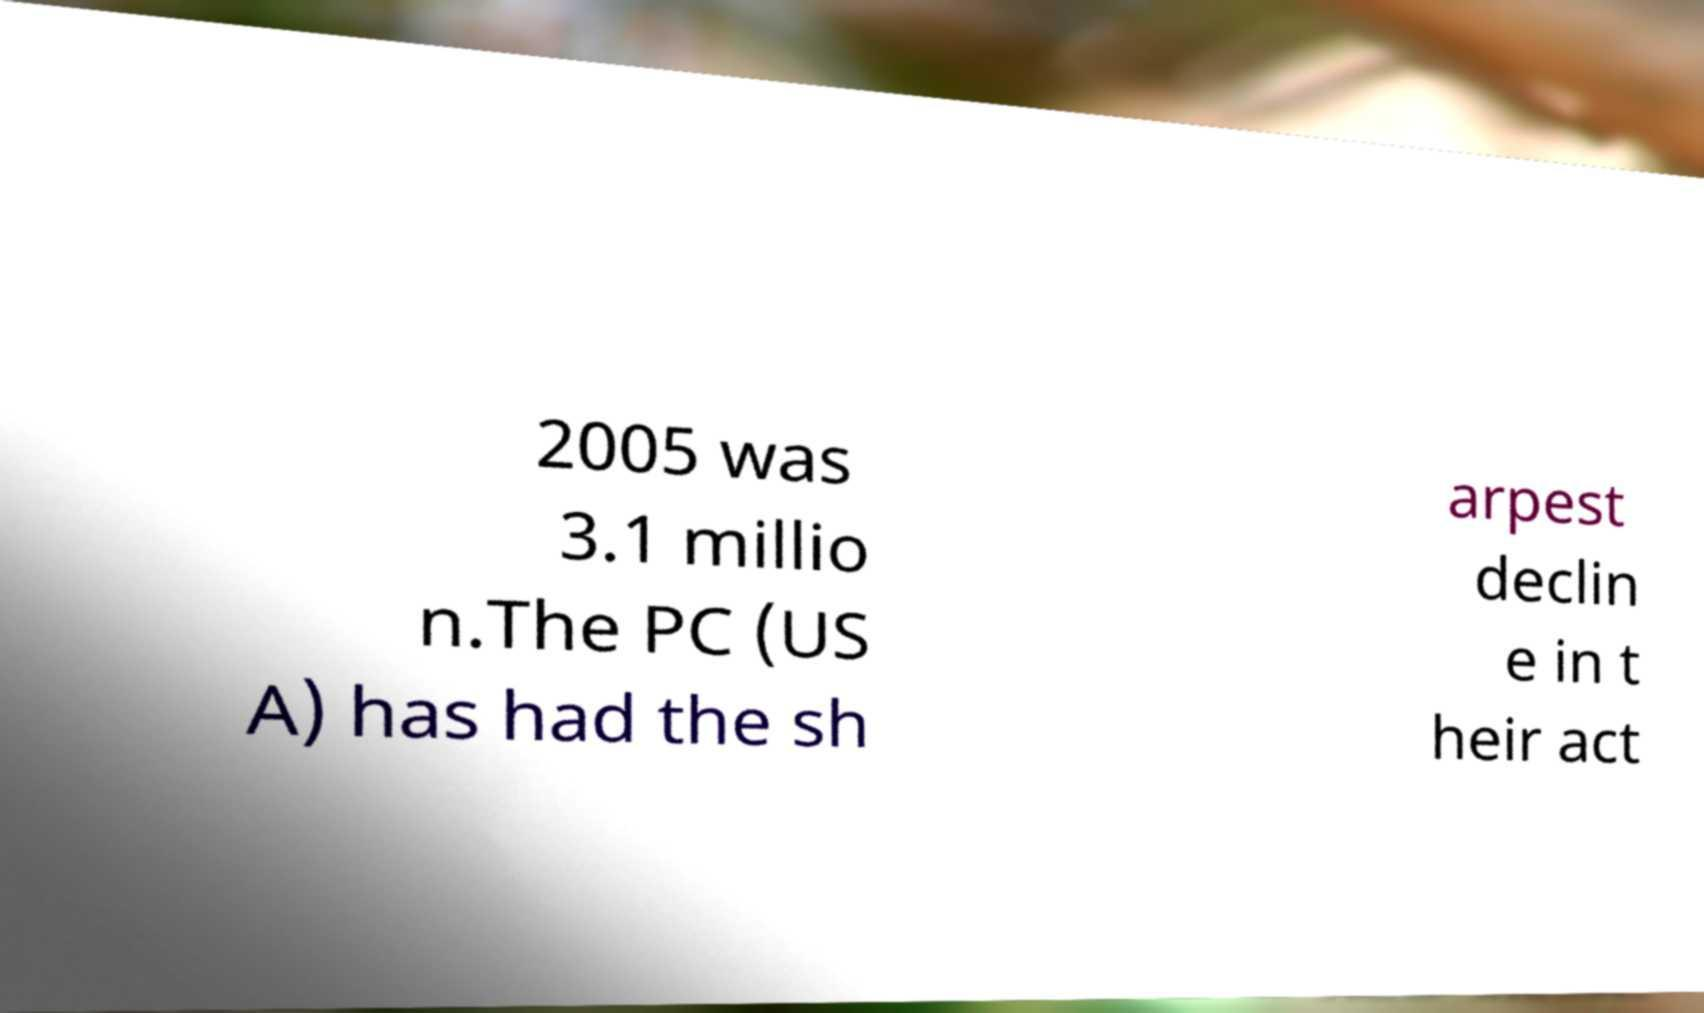Please read and relay the text visible in this image. What does it say? 2005 was 3.1 millio n.The PC (US A) has had the sh arpest declin e in t heir act 